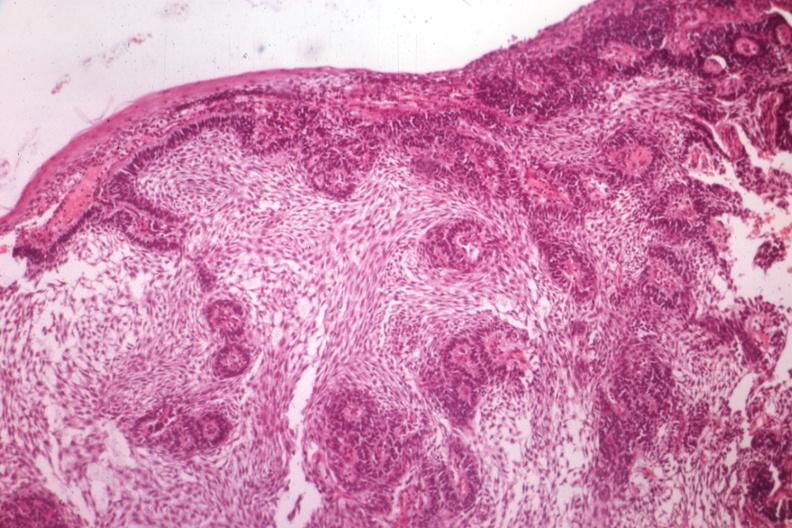s anencephaly and bilateral cleft palate present?
Answer the question using a single word or phrase. No 